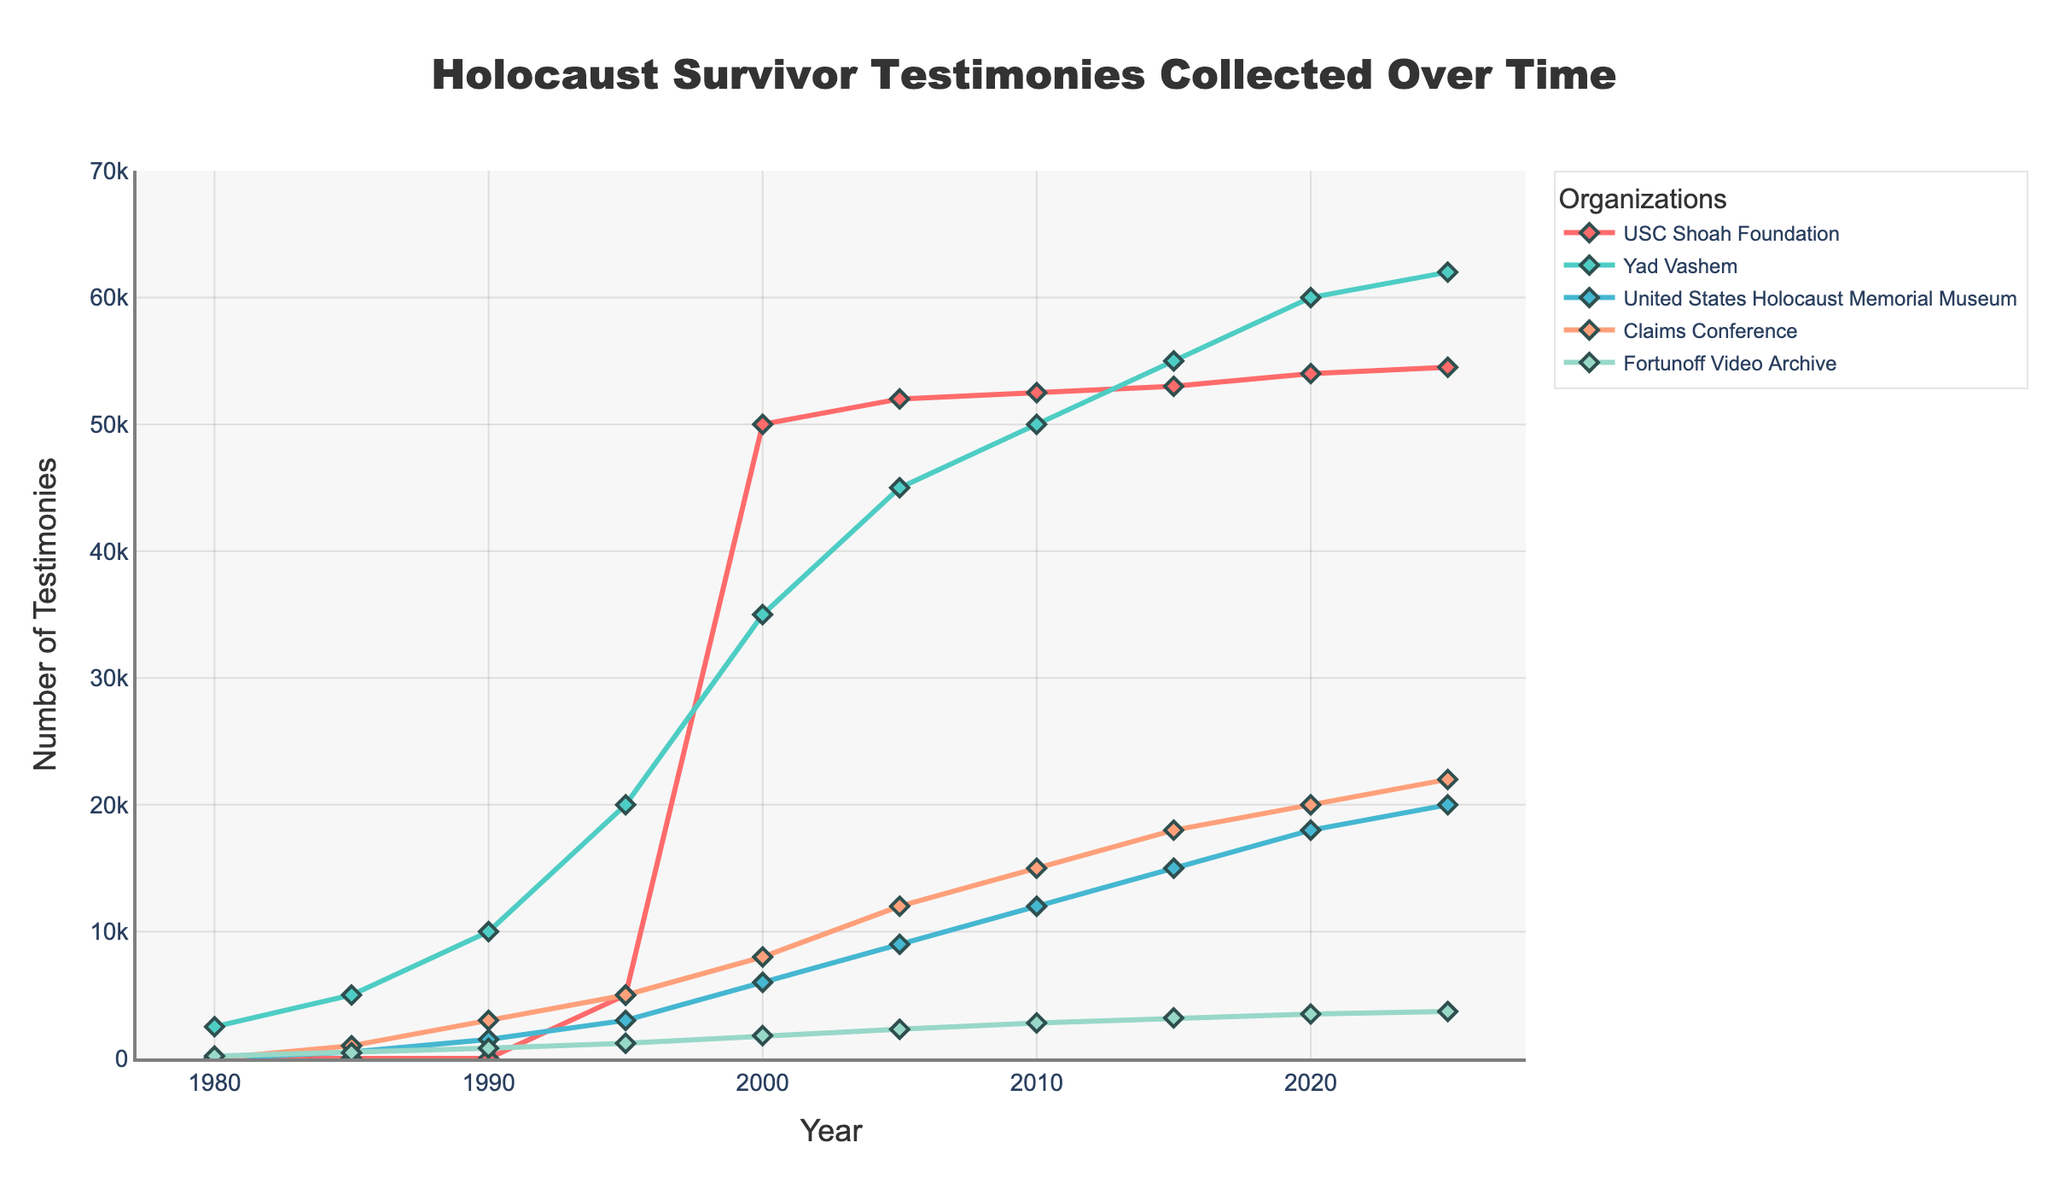What year did the USC Shoah Foundation begin collecting testimonies? The figure shows a line for the USC Shoah Foundation starting from zero. The first year with a positive count is 1995, with 5000 testimonies.
Answer: 1995 Which organization collected the most testimonies by 2025? By observing the heights of each organization's line at the year 2025, Yad Vashem has the largest value at 62,000 testimonies.
Answer: Yad Vashem What is the difference in the number of testimonies collected by the United States Holocaust Memorial Museum between 1990 and 2025? In 1990, the number of testimonies collected by the USC Shoah Foundation was 1500, and in 2025 it was 20,000. The difference is 20,000 - 1,500 = 18,500 testimonies.
Answer: 18,500 What is the total number of testimonies collected by all organizations in 2010? In 2010, USC Shoah Foundation had 52,500 testimonies, Yad Vashem had 50,000, United States Holocaust Memorial Museum had 12,000, Claims Conference had 15,000, and Fortunoff Video Archive had 2,800. Adding them up gives 52,500 + 50,000 + 12,000 + 15,000 + 2,800 = 132,300 testimonies.
Answer: 132,300 How many times did the number of testimonies collected by the Claims Conference increase from 1985 to 2025? The Claims Conference collected 1,000 testimonies in 1985 and 22,000 in 2025. The ratio is 22,000 / 1,000 = 22 times.
Answer: 22 times Which organization had the steepest increase in testimonies from 1995 to 2000? By observing the lines between 1995 and 2000, USC Shoah Foundation rose from 5,000 to 50,000, a 45,000 increase, which appears to be the steepest compared to others.
Answer: USC Shoah Foundation In which year did the Fortunoff Video Archive collect the fewest testimonies? By observing the lowest point on the Fortunoff Video Archive's line, in 1980, it registered 180 testimonies.
Answer: 1980 Compare the number of testimonies collected by USC Shoah Foundation and the Claims Conference in 2015. Which was higher and by how much? In 2015, the USC Shoah Foundation had 53,000 testimonies, and the Claims Conference had 18,000. The difference is 53,000 - 18,000 = 35,000 testimonies.
Answer: USC Shoah Foundation, 35,000 What is the average number of testimonies collected by Yad Vashem from 1980 to 2025? Summing the testimonies: 2500 (1980) + 5000 (1985) + 10000 (1990) + 20000 (1995) + 35000 (2000) + 45000 (2005) + 50000 (2010) + 55000 (2015) + 60000 (2020) + 62000 (2025) = 344500 testimonies. There are 10 data points, so the average is 344500 / 10 = 34,450.
Answer: 34,450 What is the trend observed for the USC Shoah Foundation testimonies from 2010 to 2025? From 2010 to 2025, the USC Shoah Foundation testimonies increased steadily from 52,500 to 54,500.
Answer: Steady increase 